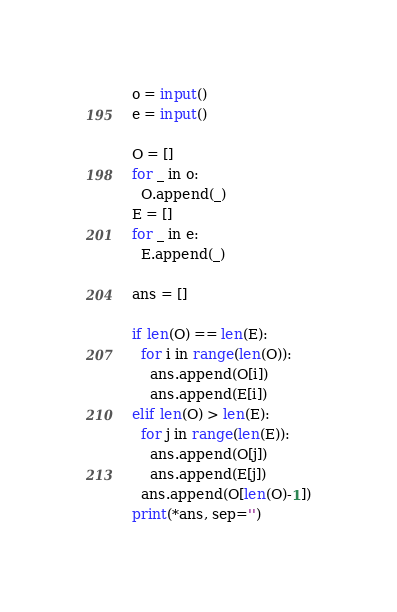Convert code to text. <code><loc_0><loc_0><loc_500><loc_500><_Python_>o = input()
e = input()

O = []
for _ in o:
  O.append(_)
E = []
for _ in e:
  E.append(_)

ans = []

if len(O) == len(E):
  for i in range(len(O)):
    ans.append(O[i])
    ans.append(E[i])
elif len(O) > len(E):
  for j in range(len(E)):
    ans.append(O[j])
    ans.append(E[j])
  ans.append(O[len(O)-1])
print(*ans, sep='')
</code> 